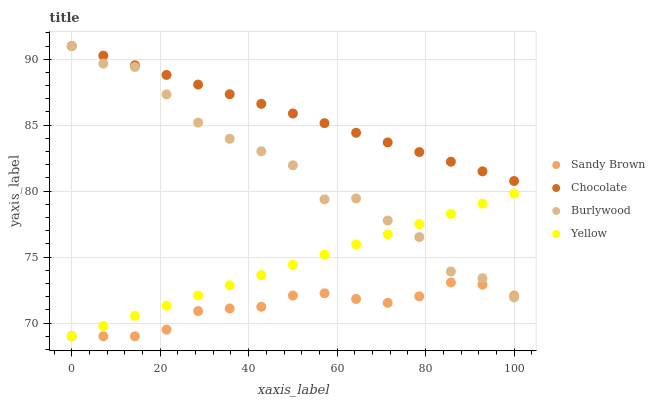Does Sandy Brown have the minimum area under the curve?
Answer yes or no. Yes. Does Chocolate have the maximum area under the curve?
Answer yes or no. Yes. Does Yellow have the minimum area under the curve?
Answer yes or no. No. Does Yellow have the maximum area under the curve?
Answer yes or no. No. Is Yellow the smoothest?
Answer yes or no. Yes. Is Burlywood the roughest?
Answer yes or no. Yes. Is Sandy Brown the smoothest?
Answer yes or no. No. Is Sandy Brown the roughest?
Answer yes or no. No. Does Sandy Brown have the lowest value?
Answer yes or no. Yes. Does Chocolate have the lowest value?
Answer yes or no. No. Does Chocolate have the highest value?
Answer yes or no. Yes. Does Yellow have the highest value?
Answer yes or no. No. Is Yellow less than Chocolate?
Answer yes or no. Yes. Is Chocolate greater than Yellow?
Answer yes or no. Yes. Does Burlywood intersect Chocolate?
Answer yes or no. Yes. Is Burlywood less than Chocolate?
Answer yes or no. No. Is Burlywood greater than Chocolate?
Answer yes or no. No. Does Yellow intersect Chocolate?
Answer yes or no. No. 